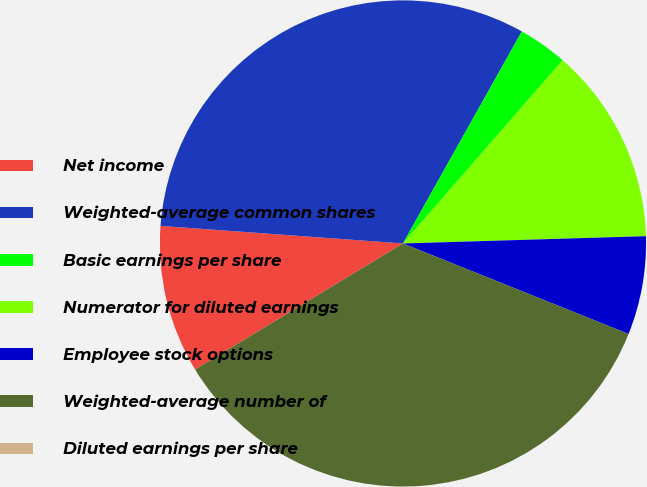<chart> <loc_0><loc_0><loc_500><loc_500><pie_chart><fcel>Net income<fcel>Weighted-average common shares<fcel>Basic earnings per share<fcel>Numerator for diluted earnings<fcel>Employee stock options<fcel>Weighted-average number of<fcel>Diluted earnings per share<nl><fcel>9.83%<fcel>31.98%<fcel>3.28%<fcel>13.11%<fcel>6.55%<fcel>35.25%<fcel>0.0%<nl></chart> 